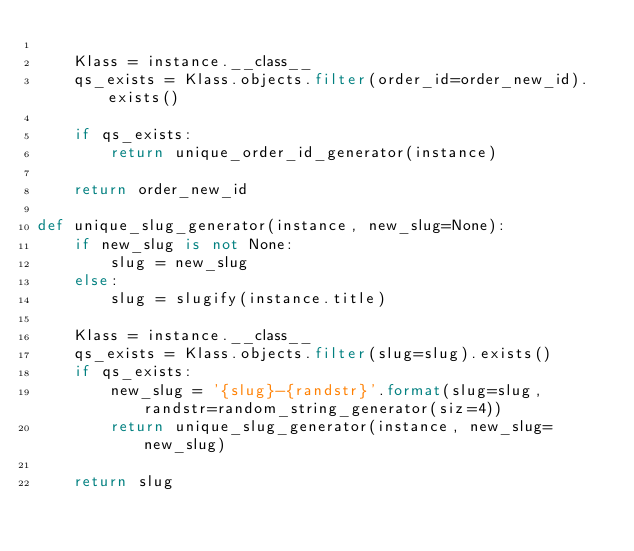Convert code to text. <code><loc_0><loc_0><loc_500><loc_500><_Python_>
    Klass = instance.__class__
    qs_exists = Klass.objects.filter(order_id=order_new_id).exists()
    
    if qs_exists:
        return unique_order_id_generator(instance)
    
    return order_new_id

def unique_slug_generator(instance, new_slug=None):
    if new_slug is not None:
        slug = new_slug
    else:
        slug = slugify(instance.title)
    
    Klass = instance.__class__
    qs_exists = Klass.objects.filter(slug=slug).exists()
    if qs_exists:
        new_slug = '{slug}-{randstr}'.format(slug=slug, randstr=random_string_generator(siz=4))
        return unique_slug_generator(instance, new_slug=new_slug)
    
    return slug
        
    
</code> 